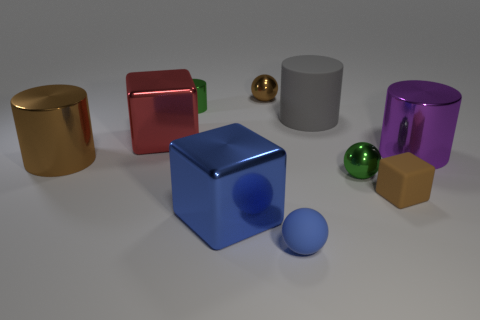What number of other things are there of the same color as the small matte ball?
Your response must be concise. 1. What material is the brown block that is the same size as the green cylinder?
Your response must be concise. Rubber. What is the material of the large thing that is the same color as the rubber block?
Give a very brief answer. Metal. Do the shiny cube that is behind the brown metal cylinder and the shiny ball that is on the right side of the gray thing have the same size?
Offer a terse response. No. The small green metal thing in front of the large brown cylinder has what shape?
Your response must be concise. Sphere. There is another large thing that is the same shape as the large blue shiny object; what is it made of?
Ensure brevity in your answer.  Metal. There is a ball that is in front of the blue shiny thing; is its size the same as the green sphere?
Keep it short and to the point. Yes. There is a large purple metallic cylinder; how many small metal things are to the right of it?
Offer a very short reply. 0. Are there fewer red metal objects that are behind the small cylinder than tiny metallic spheres that are behind the tiny brown matte thing?
Your answer should be compact. Yes. How many small brown rubber cubes are there?
Your response must be concise. 1. 